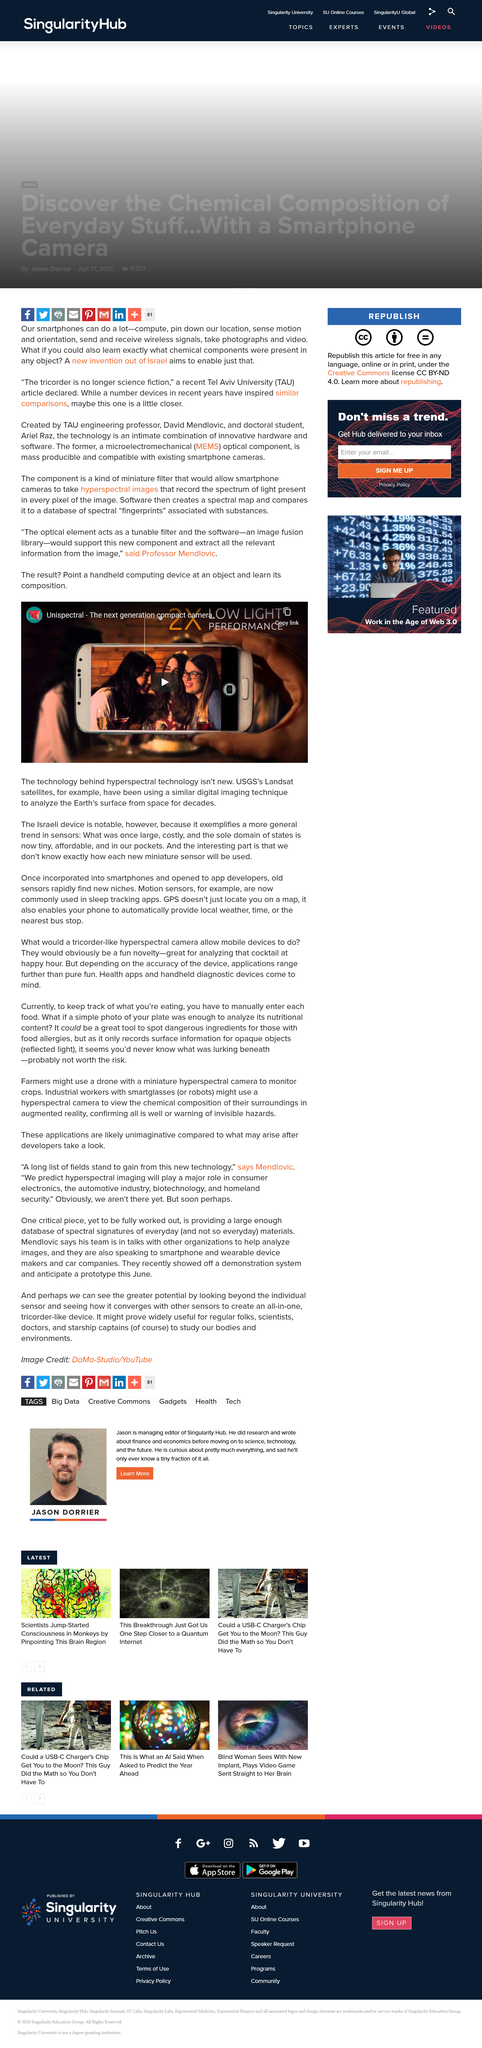Indicate a few pertinent items in this graphic. The technology underlying hyperspectral technology is not new. The video is titled 'Unispectral - the next generation compact camera.' 